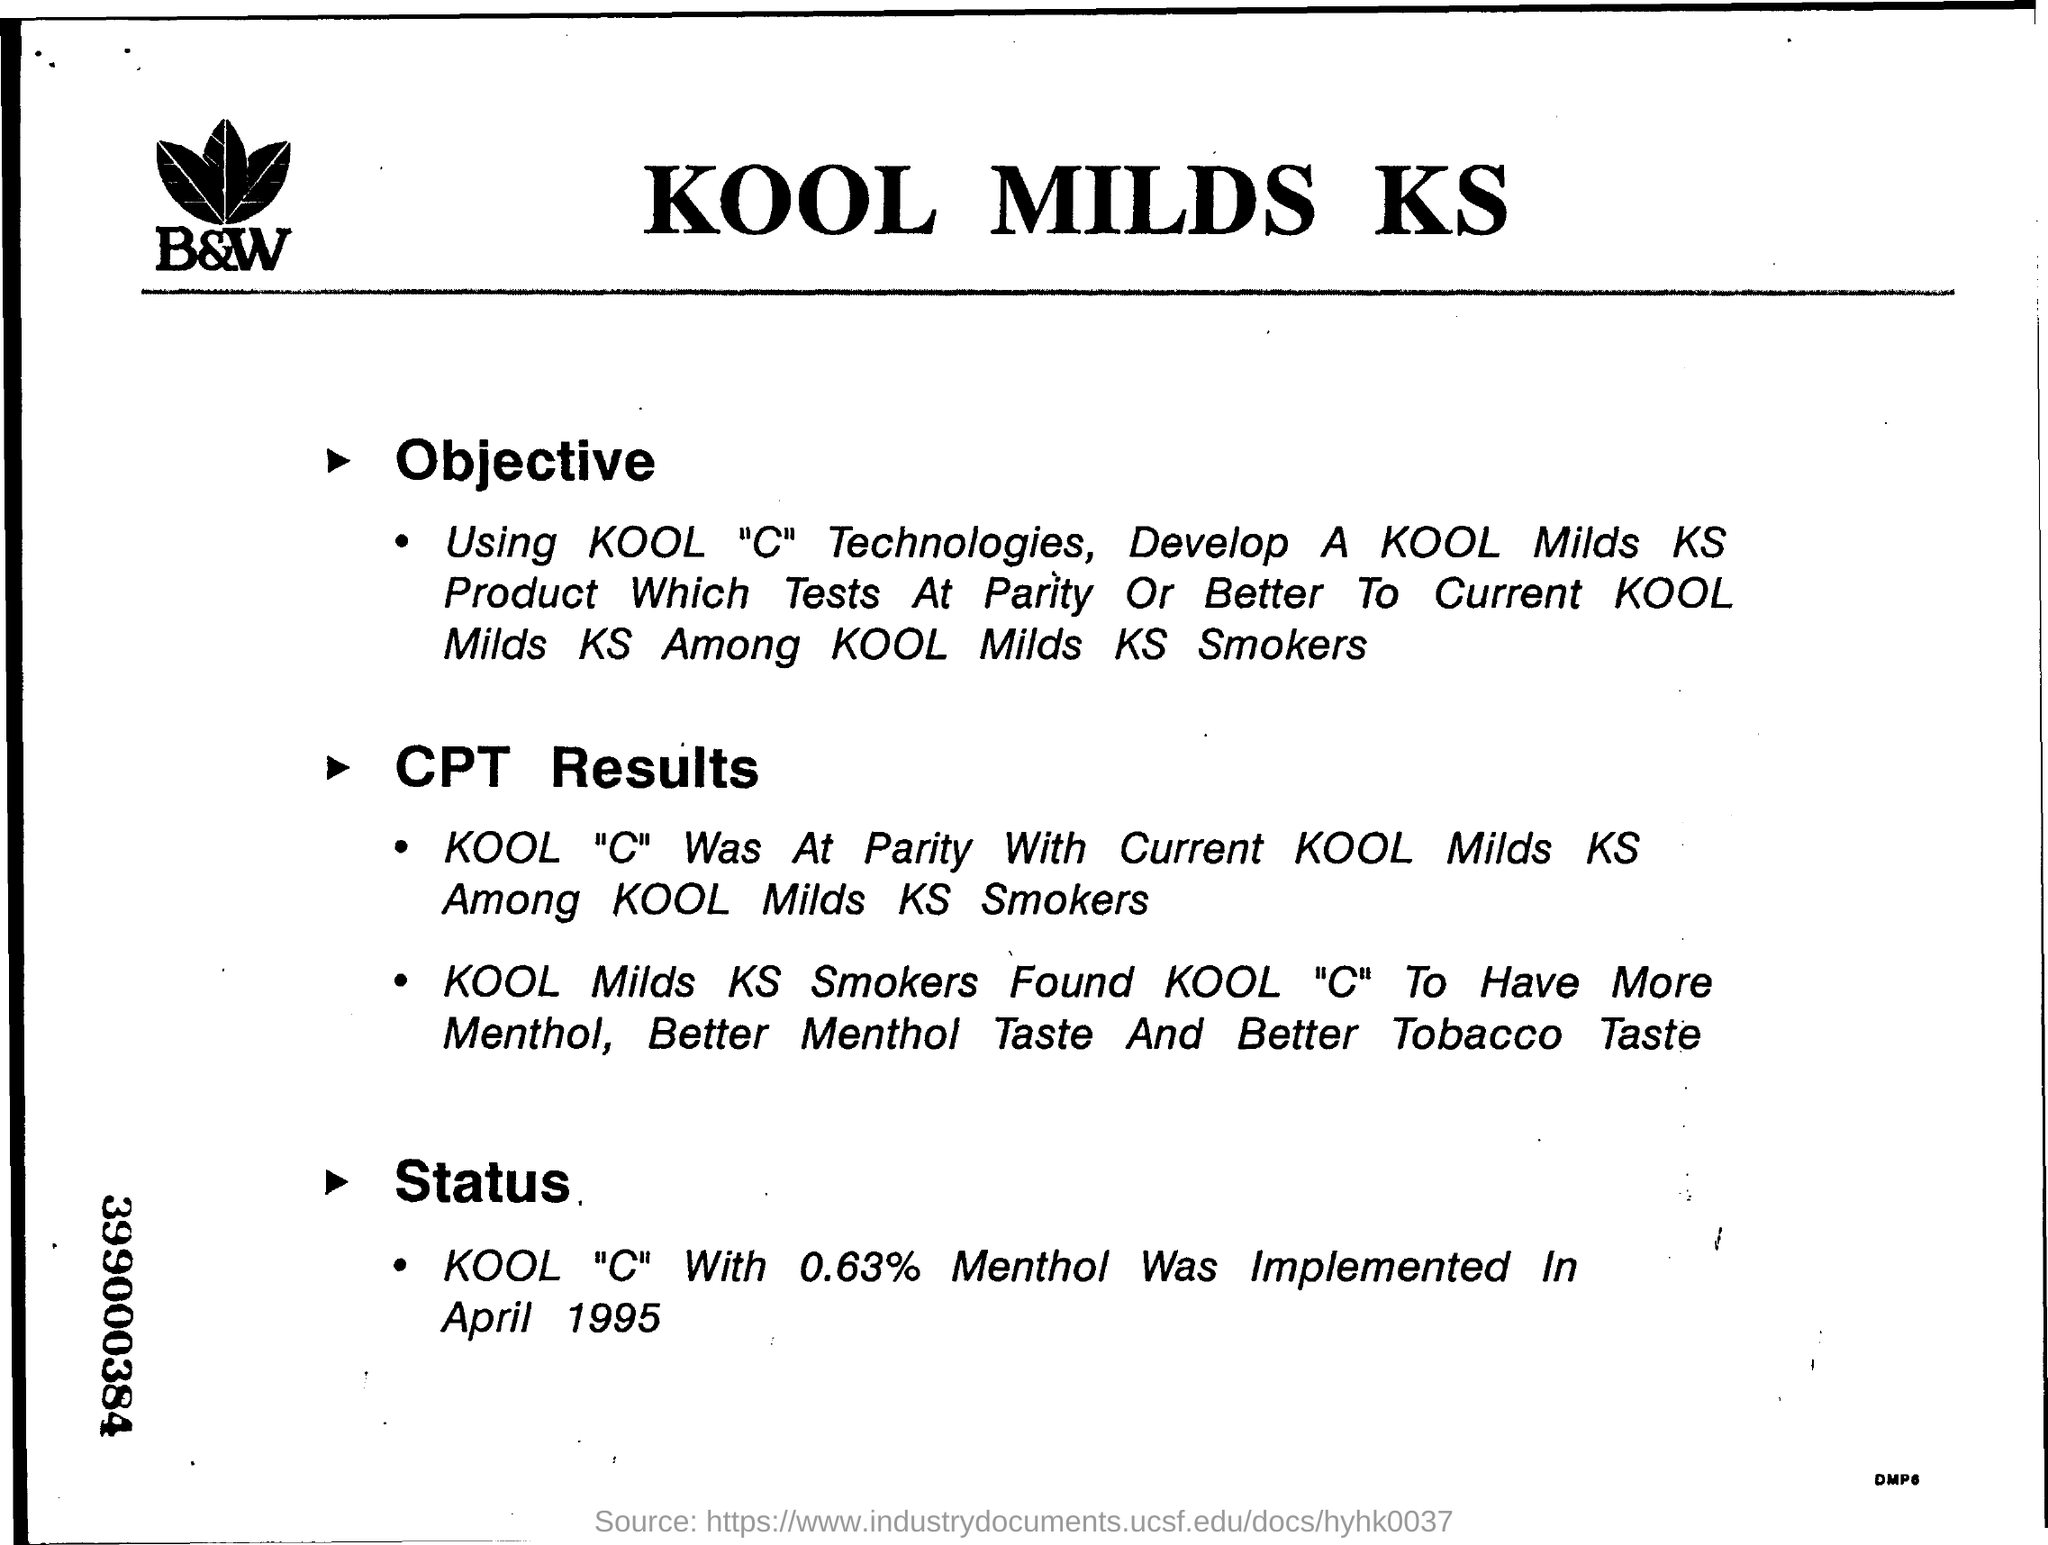Specify some key components in this picture. The name of the company is B&W. The KOOL MILDS KS was introduced in April 1995, with the "C" variant featuring 0.63% menthol. The "KOOL "C" With 0.63% Menthol" was implemented in April 1995. The objective of the KOOL MILDS KS is to utilize Kool "C" Technologies to develop a KOOL MILDS KS product that tests at parity or better to the current KOOL MILDS KS among KOOL MILDS KS smokers. 